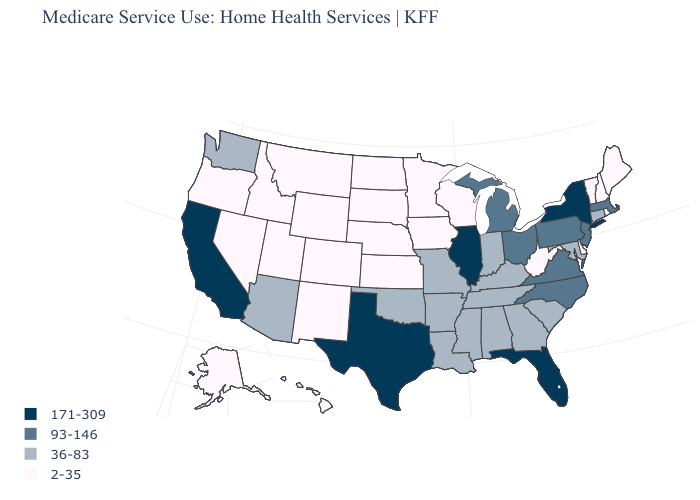What is the value of Maryland?
Answer briefly. 36-83. How many symbols are there in the legend?
Short answer required. 4. Name the states that have a value in the range 2-35?
Quick response, please. Alaska, Colorado, Delaware, Hawaii, Idaho, Iowa, Kansas, Maine, Minnesota, Montana, Nebraska, Nevada, New Hampshire, New Mexico, North Dakota, Oregon, Rhode Island, South Dakota, Utah, Vermont, West Virginia, Wisconsin, Wyoming. Which states have the lowest value in the MidWest?
Answer briefly. Iowa, Kansas, Minnesota, Nebraska, North Dakota, South Dakota, Wisconsin. Among the states that border Maryland , does Virginia have the lowest value?
Give a very brief answer. No. What is the value of Mississippi?
Concise answer only. 36-83. What is the value of Montana?
Give a very brief answer. 2-35. Name the states that have a value in the range 93-146?
Give a very brief answer. Massachusetts, Michigan, New Jersey, North Carolina, Ohio, Pennsylvania, Virginia. Which states hav the highest value in the West?
Write a very short answer. California. Does the map have missing data?
Concise answer only. No. Among the states that border South Dakota , which have the lowest value?
Keep it brief. Iowa, Minnesota, Montana, Nebraska, North Dakota, Wyoming. What is the highest value in the Northeast ?
Give a very brief answer. 171-309. Does New Jersey have the lowest value in the Northeast?
Quick response, please. No. What is the value of Oklahoma?
Answer briefly. 36-83. Name the states that have a value in the range 93-146?
Be succinct. Massachusetts, Michigan, New Jersey, North Carolina, Ohio, Pennsylvania, Virginia. 